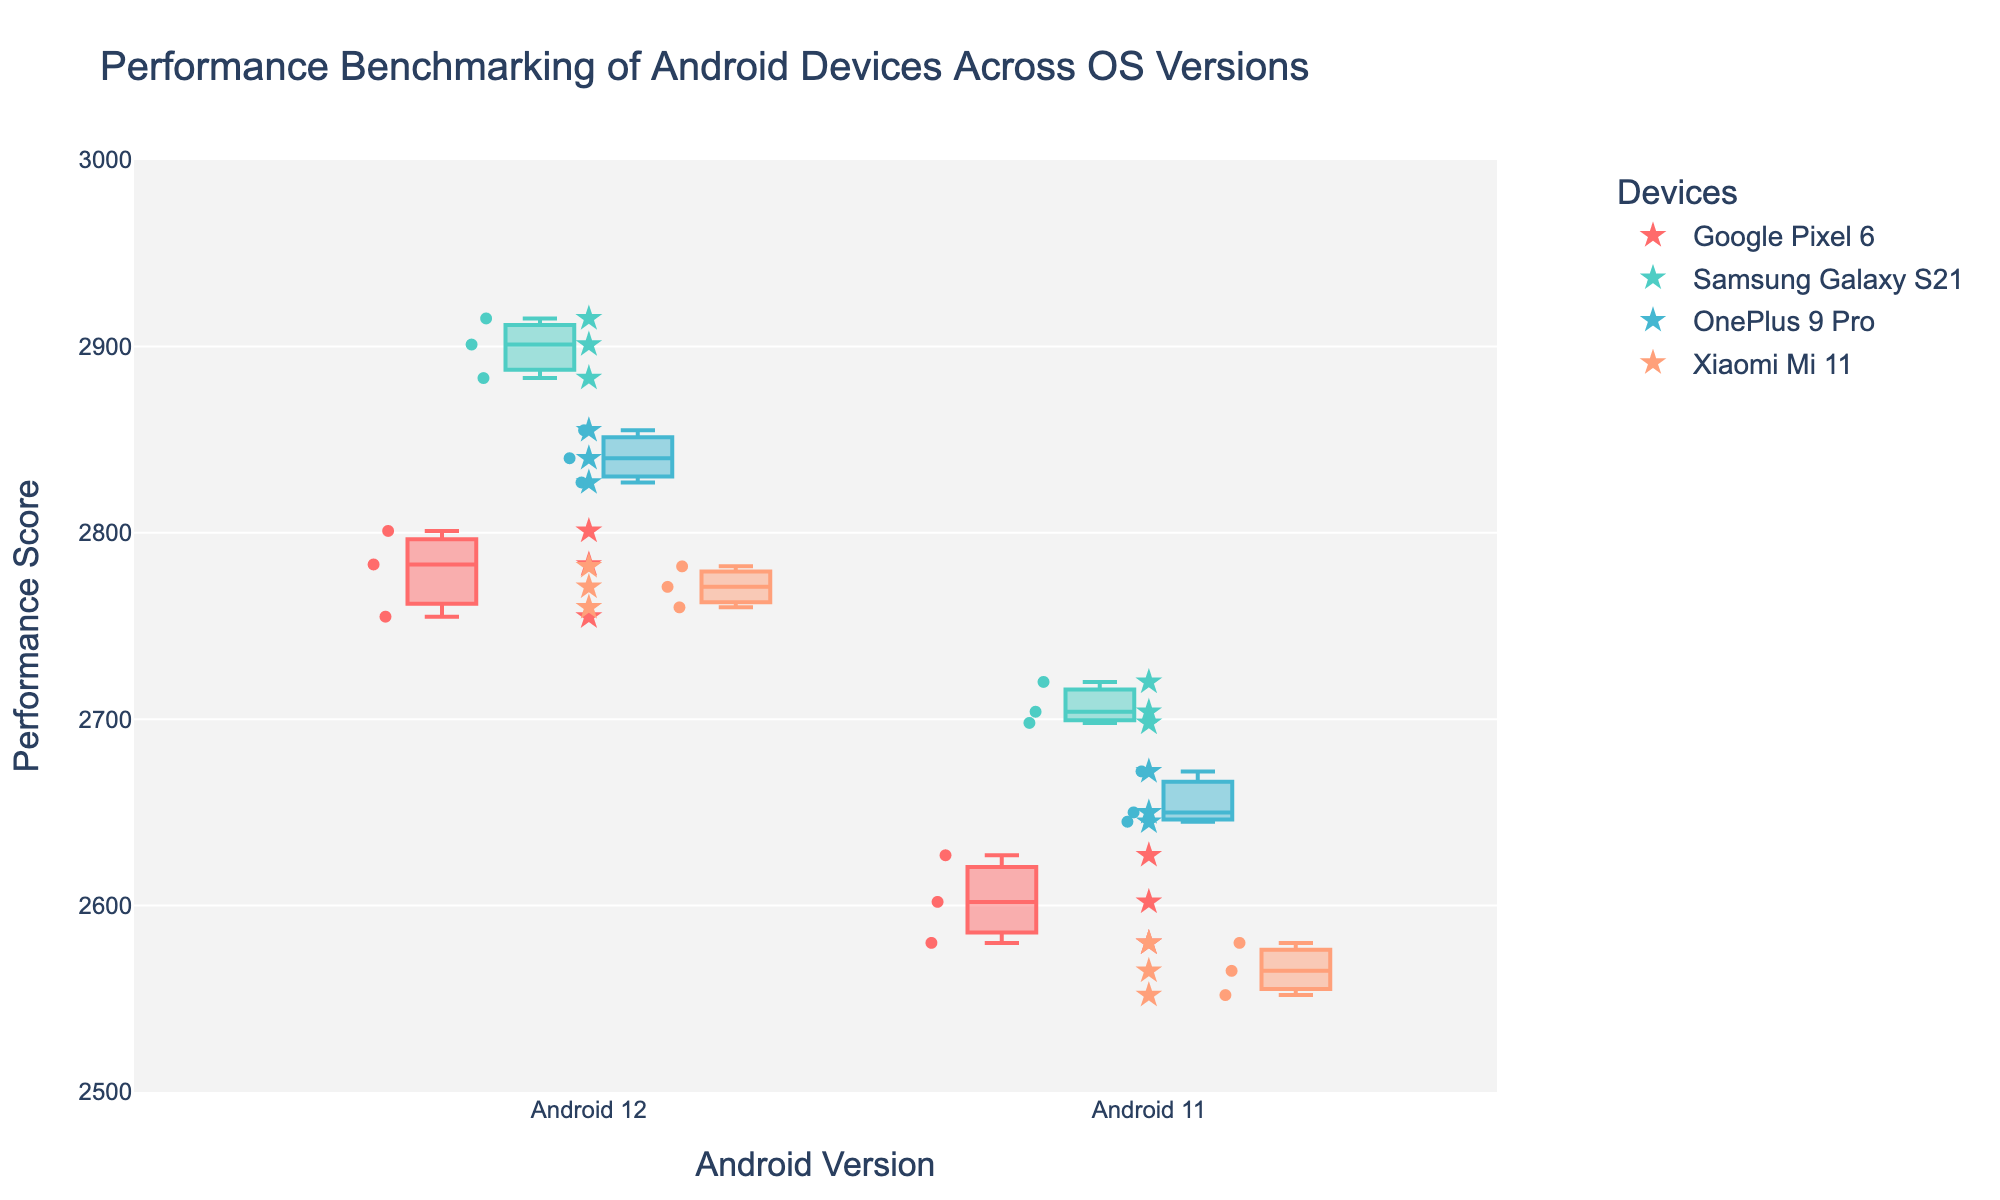Which device has the highest performance score on Android 12? The scatter plot markers show the performance scores for each device, and the highest marker on Android 12 belongs to the Samsung Galaxy S21.
Answer: Samsung Galaxy S21 What is the median performance score for the Google Pixel 6 on Android 11? To determine the median score, locate the distribution for the Google Pixel 6 on Android 11 in the box plot and find the central tendency (the line inside the box).
Answer: 2602 How does the performance of OnePlus 9 Pro on Android 12 compare to Android 11? Comparing the boxes for OnePlus 9 Pro on both OS versions, Android 12 has a higher median, and the performance scores are overall higher than those on Android 11.
Answer: Higher on Android 12 Which Android version has a greater performance score variance for Xiaomi Mi 11? By inspecting the spread of the box plots for Xiaomi Mi 11, Android 12 has a narrower interquartile range compared to Android 11, indicating less variance on Android 12.
Answer: Android 11 On which Android version does Google Pixel 6 perform better? Compare the medians of the box plots for Google Pixel 6; Android 12 has a higher median performance score than Android 11.
Answer: Android 12 How many data points are there for Samsung Galaxy S21 on Android 11? Counting the number of scatter points on Android 11 for Samsung Galaxy S21, there should be three points.
Answer: 3 Which device shows the smallest improvement in median performance score moving from Android 11 to Android 12? By comparing the median lines in box plots for each device across versions, Google Pixel 6 shows a smaller improvement compared to the others.
Answer: Google Pixel 6 How do the outliers for Samsung Galaxy S21 vary between Android 11 and Android 12? Outliers are individual points that fall outside the whiskers of the box plot. For Samsung Galaxy S21, there are no distinct outliers beyond the whiskers for both versions.
Answer: No significant outliers Does any device have overlapping performance scores across both Android versions? Check if any whiskers or box ends, which indicate the range, overlap between versions for a single device; yes, Xiaomi Mi 11 has overlapping scores.
Answer: Yes, Xiaomi Mi 11 